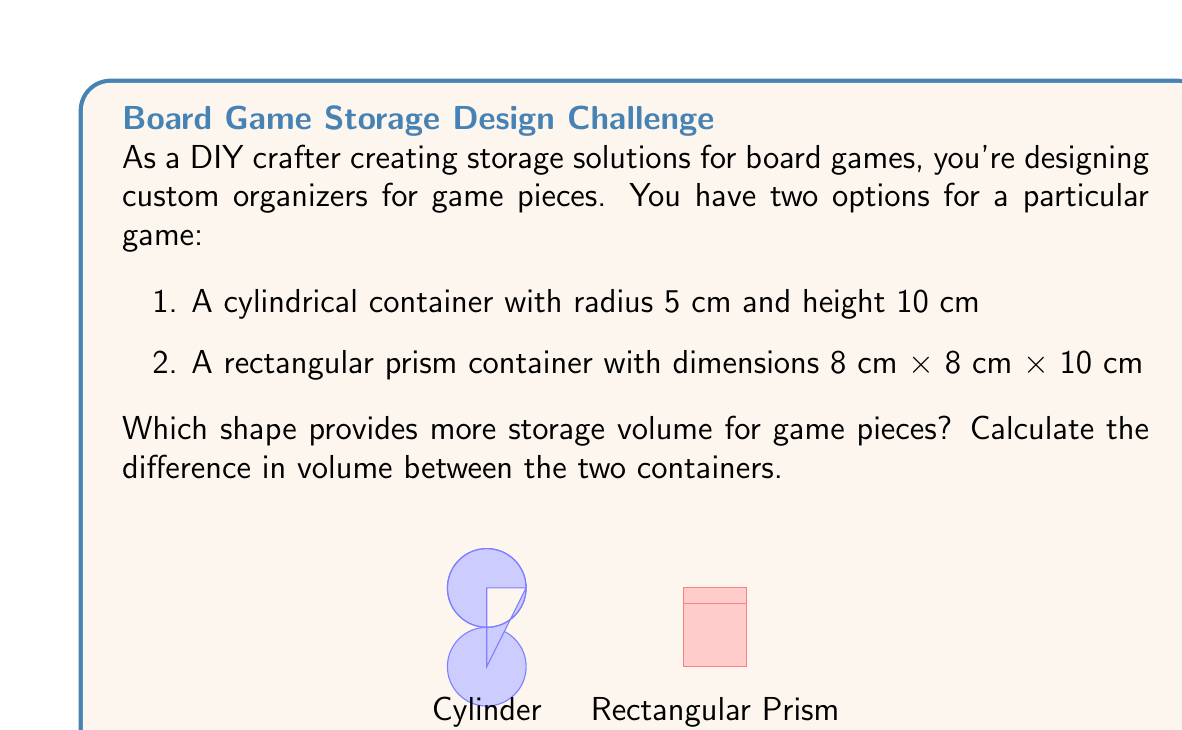Provide a solution to this math problem. Let's approach this step-by-step:

1) For the cylindrical container:
   Volume of a cylinder is given by the formula $V = \pi r^2 h$
   where $r$ is the radius and $h$ is the height.
   
   $V_{cylinder} = \pi * (5\text{ cm})^2 * 10\text{ cm}$
   $V_{cylinder} = 250\pi\text{ cm}^3$
   $V_{cylinder} \approx 785.40\text{ cm}^3$

2) For the rectangular prism container:
   Volume of a rectangular prism is given by $V = l * w * h$
   where $l$ is length, $w$ is width, and $h$ is height.
   
   $V_{prism} = 8\text{ cm} * 8\text{ cm} * 10\text{ cm}$
   $V_{prism} = 640\text{ cm}^3$

3) To find the difference, we subtract:

   $\text{Difference} = V_{cylinder} - V_{prism}$
   $\text{Difference} = 785.40\text{ cm}^3 - 640\text{ cm}^3$
   $\text{Difference} = 145.40\text{ cm}^3$

Therefore, the cylindrical container provides more storage volume, with a difference of approximately 145.40 cm³.
Answer: 145.40 cm³ more in cylindrical container 